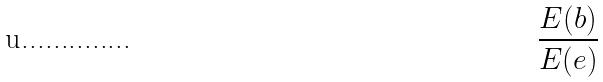<formula> <loc_0><loc_0><loc_500><loc_500>\frac { E ( b ) } { E ( e ) }</formula> 